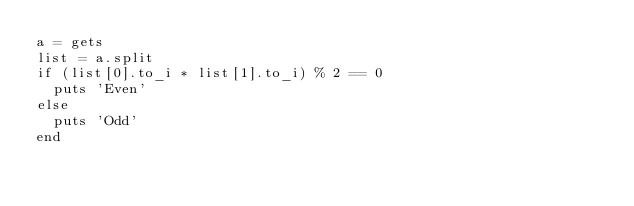Convert code to text. <code><loc_0><loc_0><loc_500><loc_500><_Ruby_>a = gets
list = a.split
if (list[0].to_i * list[1].to_i) % 2 == 0
  puts 'Even'
else
  puts 'Odd'
end
</code> 